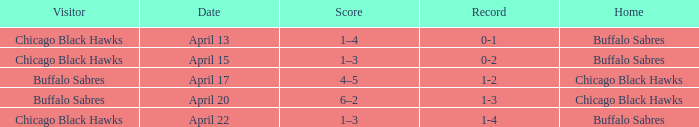Which Date has a Record of 1-4? April 22. 